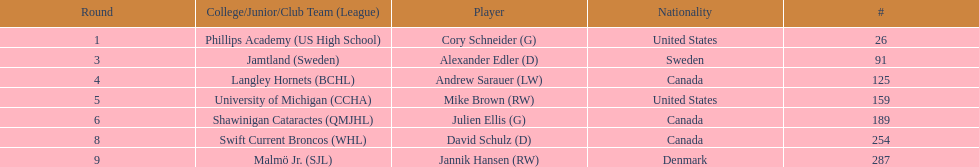Which players are not from denmark? Cory Schneider (G), Alexander Edler (D), Andrew Sarauer (LW), Mike Brown (RW), Julien Ellis (G), David Schulz (D). Can you give me this table as a dict? {'header': ['Round', 'College/Junior/Club Team (League)', 'Player', 'Nationality', '#'], 'rows': [['1', 'Phillips Academy (US High School)', 'Cory Schneider (G)', 'United States', '26'], ['3', 'Jamtland (Sweden)', 'Alexander Edler (D)', 'Sweden', '91'], ['4', 'Langley Hornets (BCHL)', 'Andrew Sarauer (LW)', 'Canada', '125'], ['5', 'University of Michigan (CCHA)', 'Mike Brown (RW)', 'United States', '159'], ['6', 'Shawinigan Cataractes (QMJHL)', 'Julien Ellis (G)', 'Canada', '189'], ['8', 'Swift Current Broncos (WHL)', 'David Schulz (D)', 'Canada', '254'], ['9', 'Malmö Jr. (SJL)', 'Jannik Hansen (RW)', 'Denmark', '287']]} 